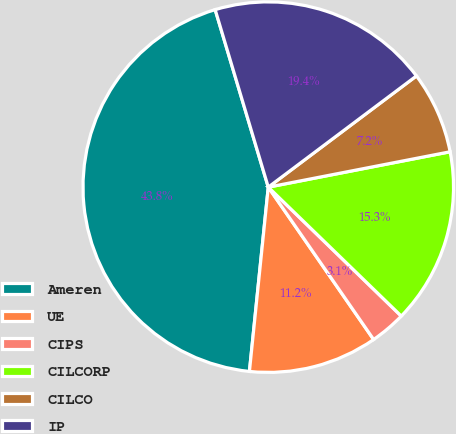Convert chart. <chart><loc_0><loc_0><loc_500><loc_500><pie_chart><fcel>Ameren<fcel>UE<fcel>CIPS<fcel>CILCORP<fcel>CILCO<fcel>IP<nl><fcel>43.75%<fcel>11.25%<fcel>3.12%<fcel>15.31%<fcel>7.19%<fcel>19.38%<nl></chart> 